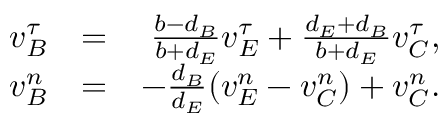<formula> <loc_0><loc_0><loc_500><loc_500>\begin{array} { r l r } { v _ { B } ^ { \tau } } & { = } & { \frac { b - d _ { B } } { b + d _ { E } } v _ { E } ^ { \tau } + \frac { d _ { E } + d _ { B } } { b + d _ { E } } v _ { C } ^ { \tau } , } \\ { v _ { B } ^ { n } } & { = } & { - \frac { d _ { B } } { d _ { E } } ( v _ { E } ^ { n } - v _ { C } ^ { n } ) + v _ { C } ^ { n } . } \end{array}</formula> 